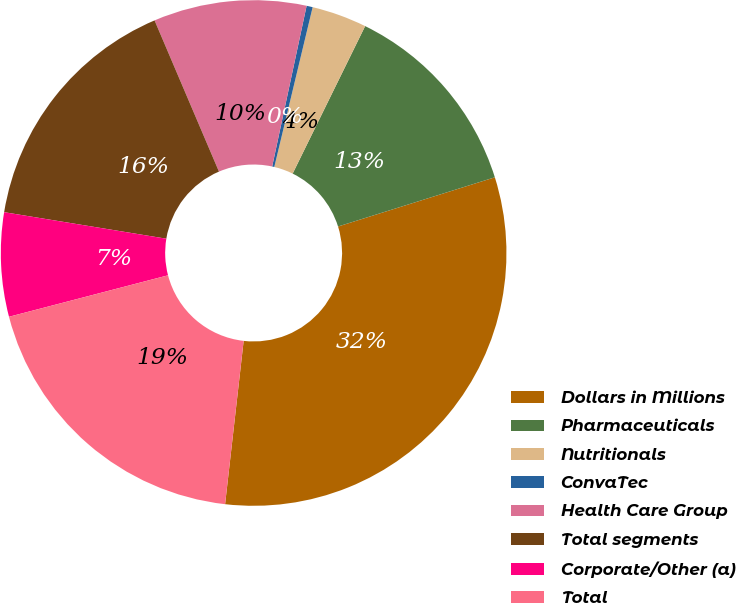Convert chart. <chart><loc_0><loc_0><loc_500><loc_500><pie_chart><fcel>Dollars in Millions<fcel>Pharmaceuticals<fcel>Nutritionals<fcel>ConvaTec<fcel>Health Care Group<fcel>Total segments<fcel>Corporate/Other (a)<fcel>Total<nl><fcel>31.64%<fcel>12.89%<fcel>3.52%<fcel>0.39%<fcel>9.77%<fcel>16.01%<fcel>6.64%<fcel>19.14%<nl></chart> 